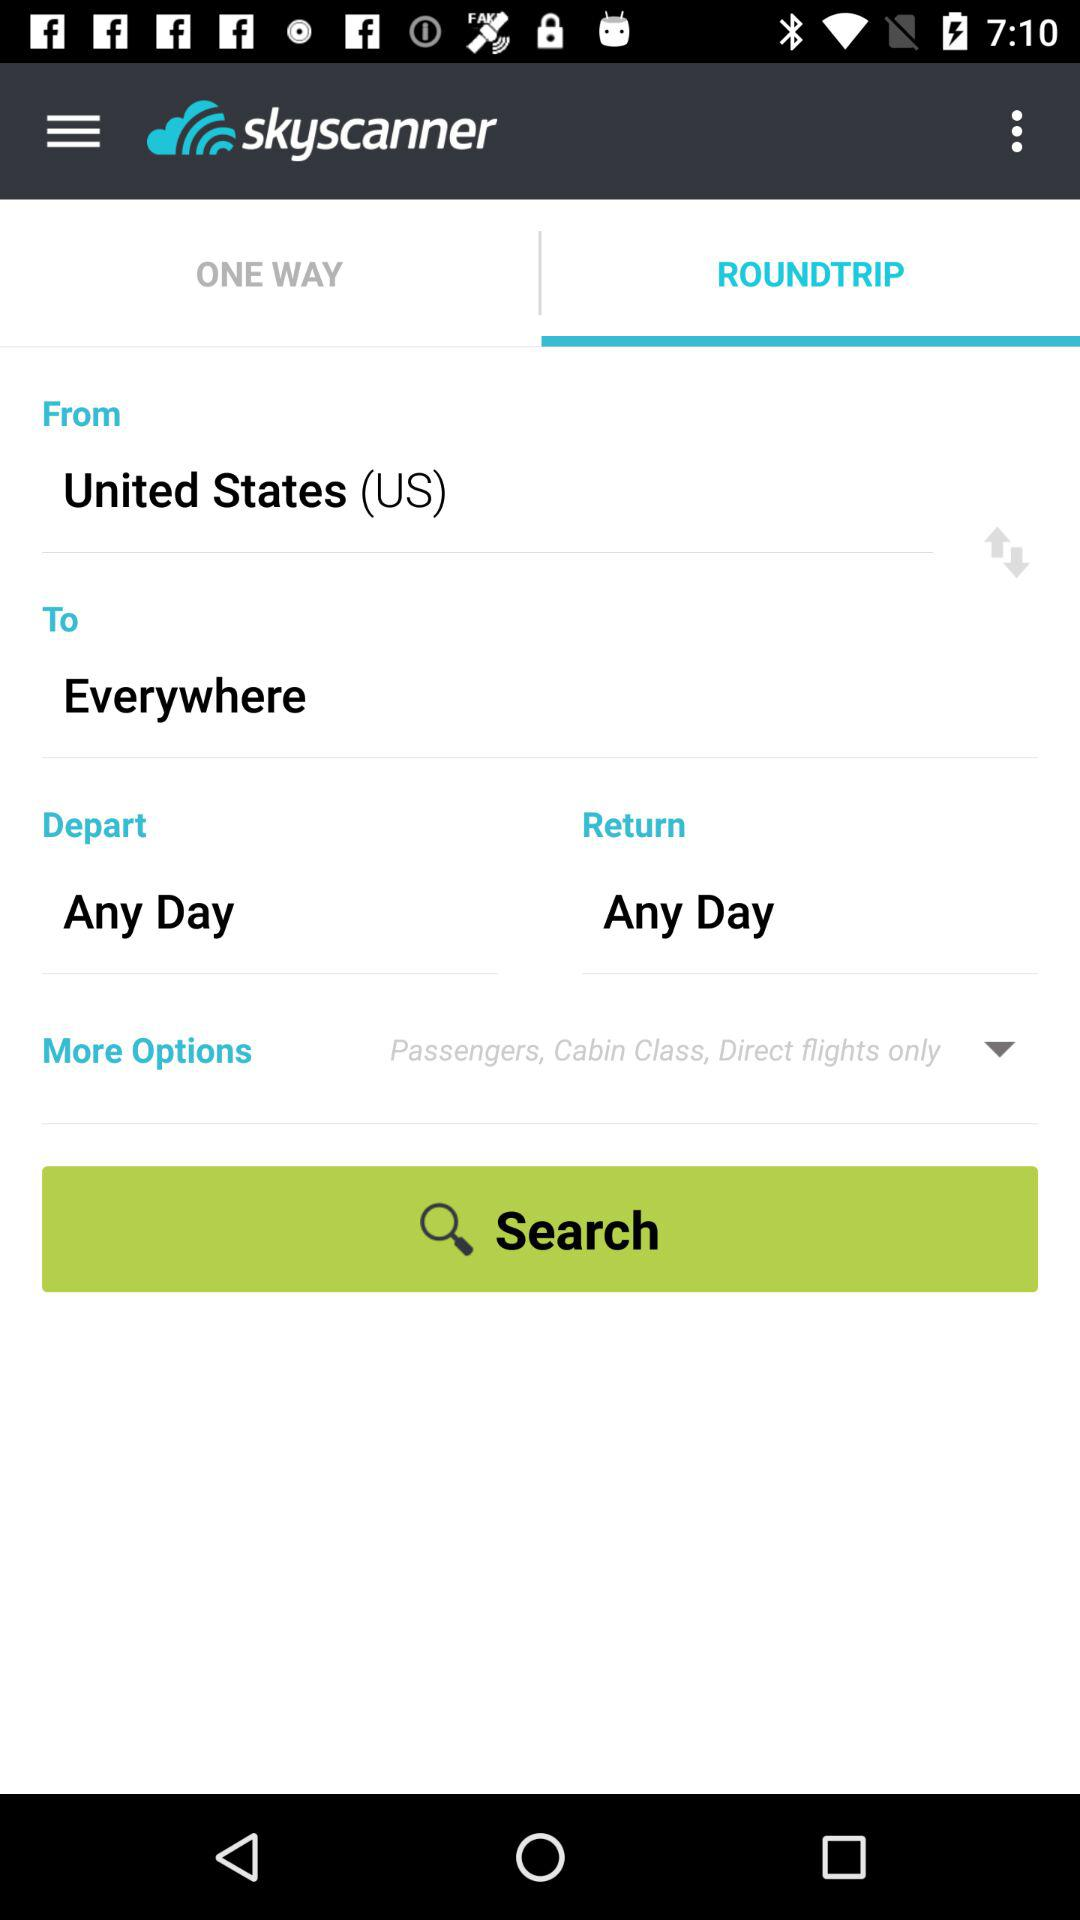What is the location? The location is the United States (US). 